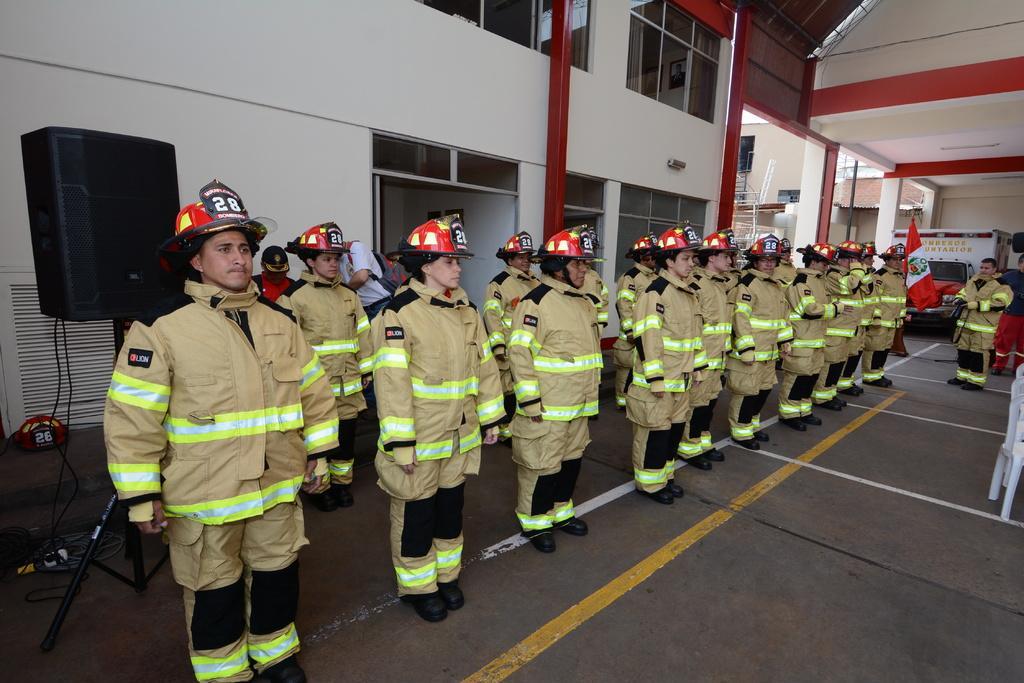In one or two sentences, can you explain what this image depicts? In the image there are a group of officers standing in a row and in front of them there is another officer, behind them on the left side there is a speaker and in the background there is a wall and there are many windows to the wall. On the right side there are two pillars. 